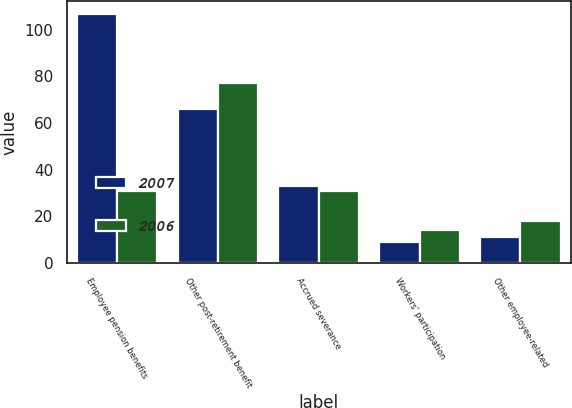Convert chart. <chart><loc_0><loc_0><loc_500><loc_500><stacked_bar_chart><ecel><fcel>Employee pension benefits<fcel>Other post-retirement benefit<fcel>Accrued severance<fcel>Workers' participation<fcel>Other employee-related<nl><fcel>2007<fcel>107<fcel>66<fcel>33<fcel>9<fcel>11<nl><fcel>2006<fcel>31<fcel>77<fcel>31<fcel>14<fcel>18<nl></chart> 